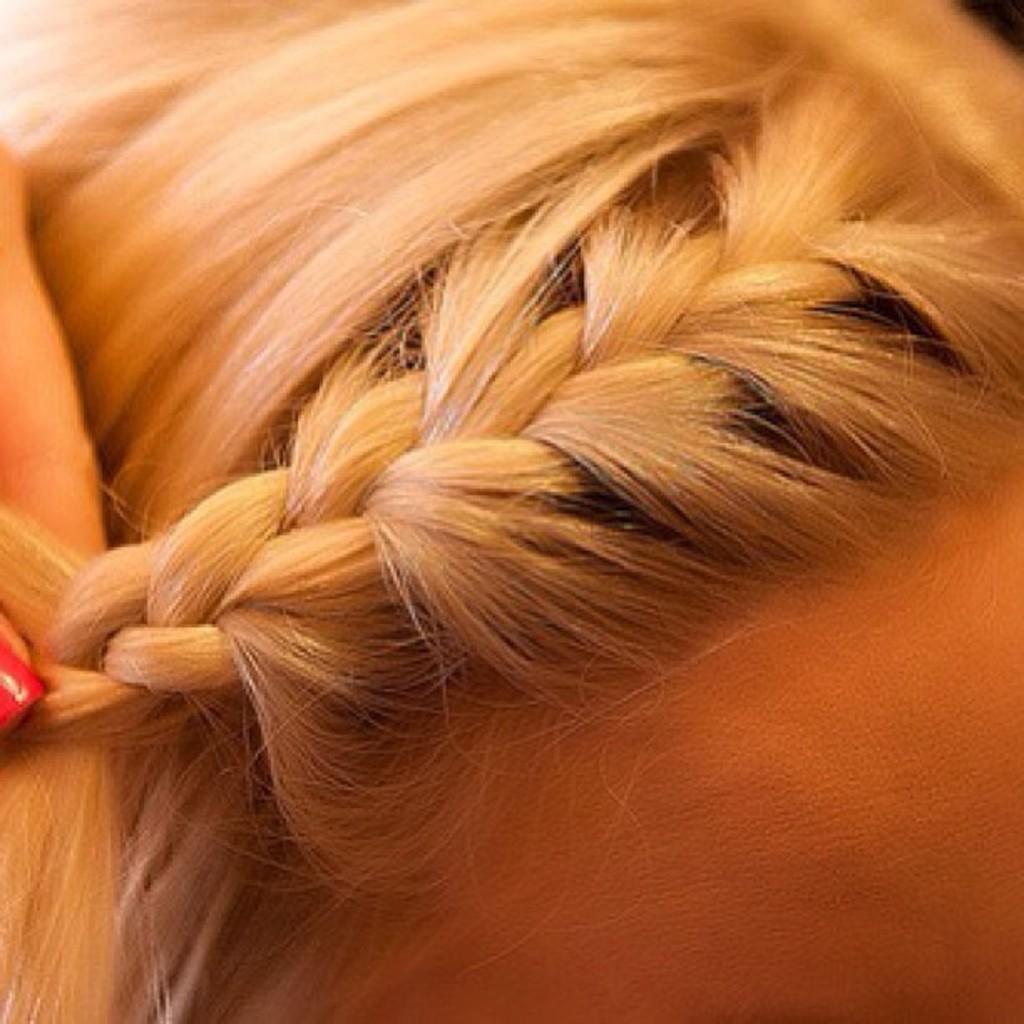How would you summarize this image in a sentence or two? In this picture we can see a person's hand dressing the hair style. 